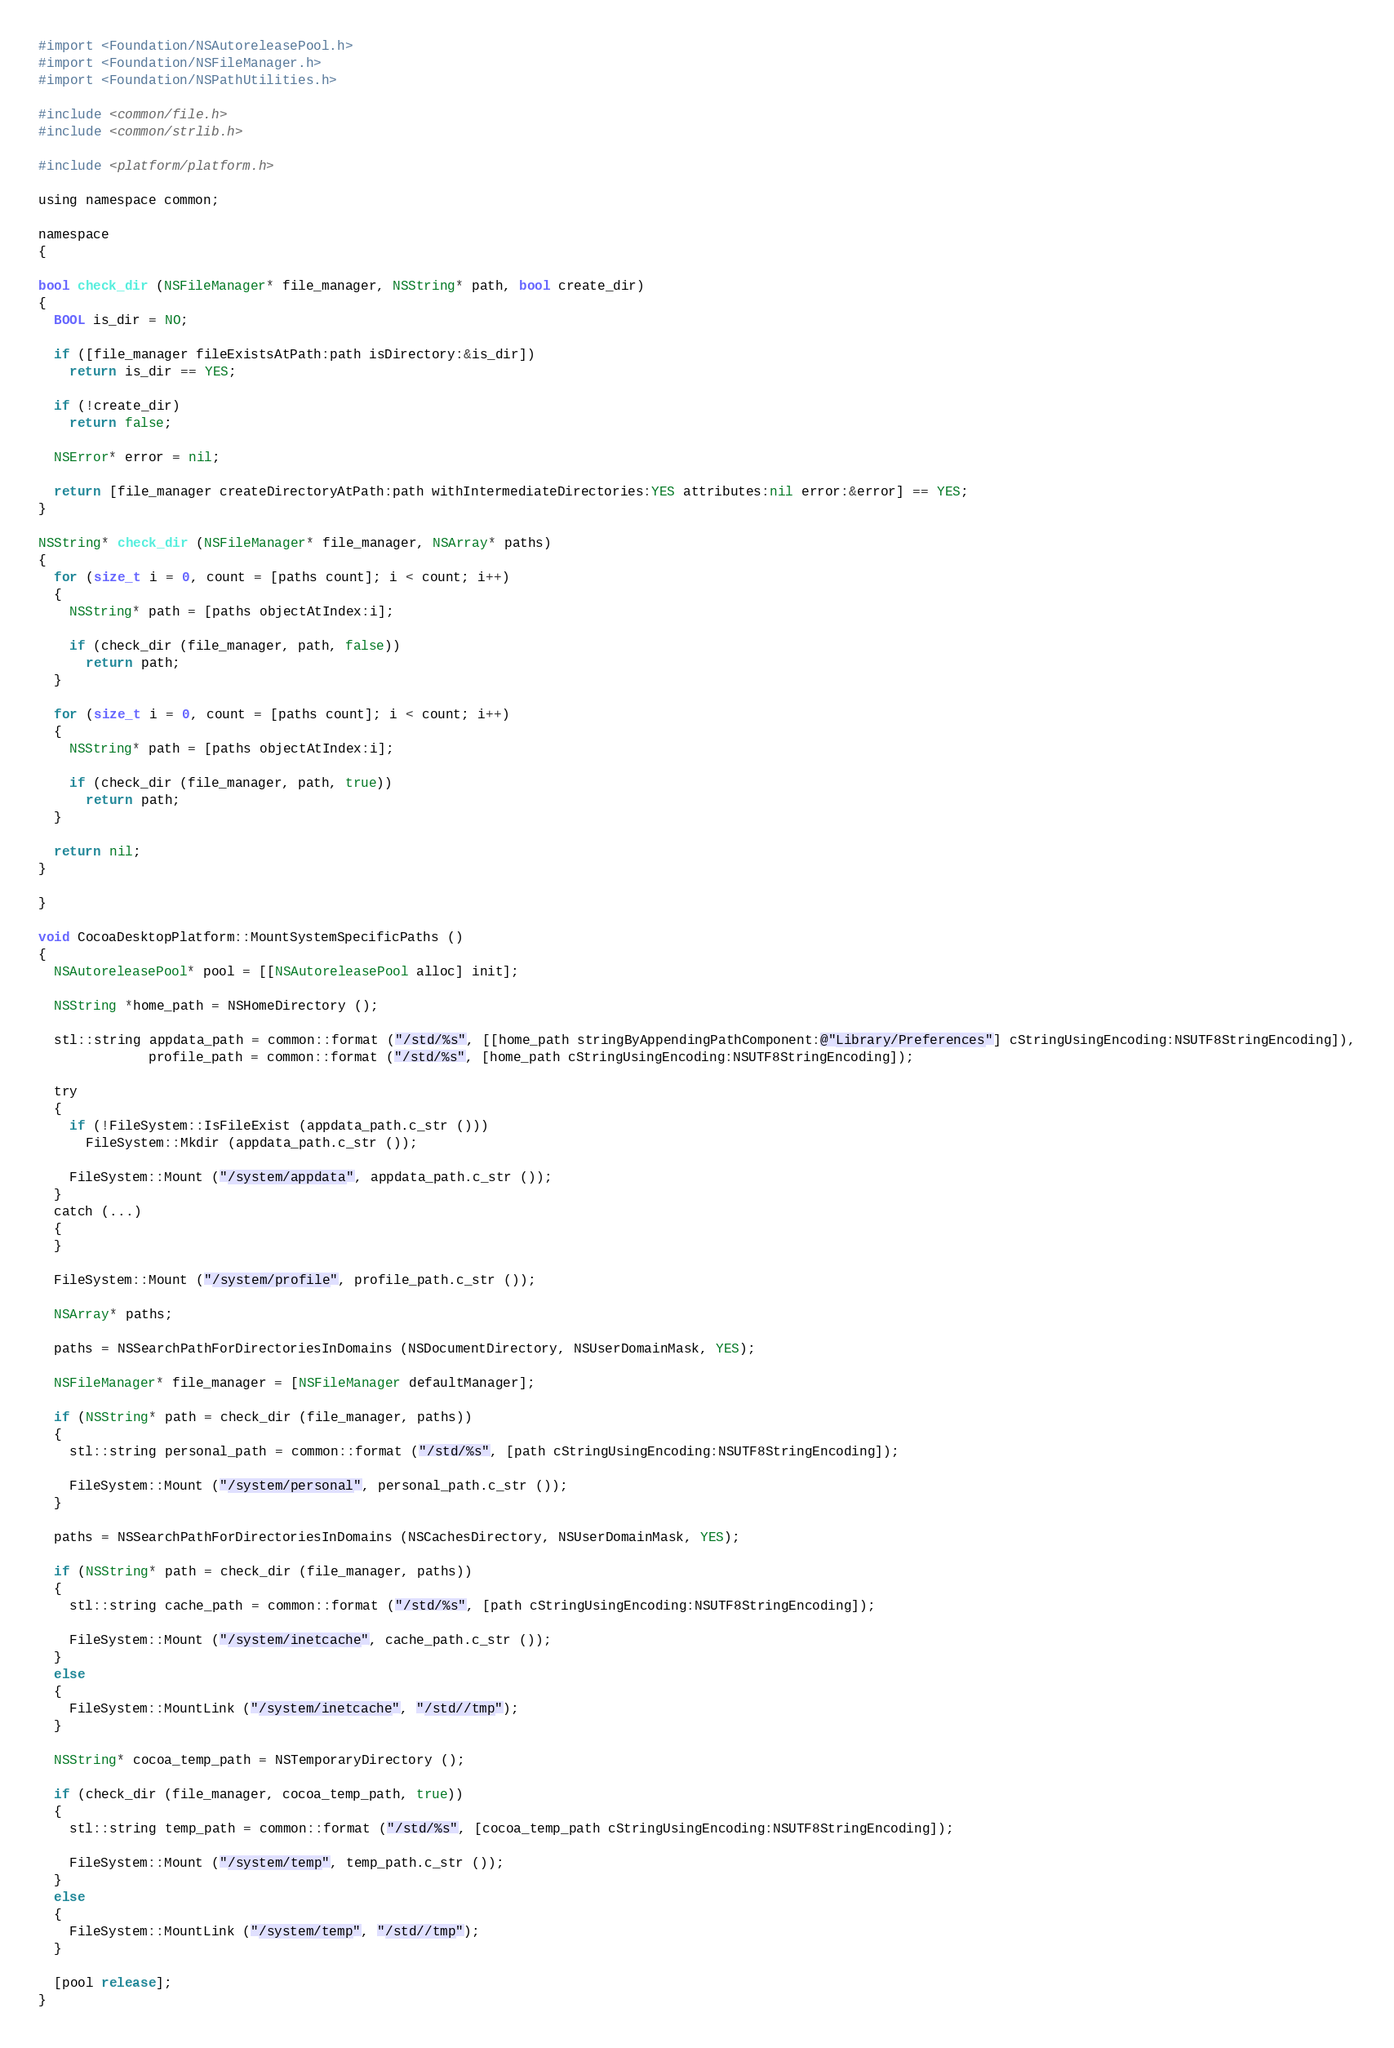Convert code to text. <code><loc_0><loc_0><loc_500><loc_500><_ObjectiveC_>#import <Foundation/NSAutoreleasePool.h>
#import <Foundation/NSFileManager.h>
#import <Foundation/NSPathUtilities.h>

#include <common/file.h>
#include <common/strlib.h>

#include <platform/platform.h>

using namespace common;

namespace
{

bool check_dir (NSFileManager* file_manager, NSString* path, bool create_dir)
{
  BOOL is_dir = NO;

  if ([file_manager fileExistsAtPath:path isDirectory:&is_dir])
    return is_dir == YES;

  if (!create_dir)
    return false;

  NSError* error = nil;

  return [file_manager createDirectoryAtPath:path withIntermediateDirectories:YES attributes:nil error:&error] == YES;
}

NSString* check_dir (NSFileManager* file_manager, NSArray* paths)
{
  for (size_t i = 0, count = [paths count]; i < count; i++)
  {
    NSString* path = [paths objectAtIndex:i];

    if (check_dir (file_manager, path, false))
      return path;
  }

  for (size_t i = 0, count = [paths count]; i < count; i++)
  {
    NSString* path = [paths objectAtIndex:i];

    if (check_dir (file_manager, path, true))
      return path;
  }

  return nil;
}

}

void CocoaDesktopPlatform::MountSystemSpecificPaths ()
{
  NSAutoreleasePool* pool = [[NSAutoreleasePool alloc] init];

  NSString *home_path = NSHomeDirectory ();

  stl::string appdata_path = common::format ("/std/%s", [[home_path stringByAppendingPathComponent:@"Library/Preferences"] cStringUsingEncoding:NSUTF8StringEncoding]),
              profile_path = common::format ("/std/%s", [home_path cStringUsingEncoding:NSUTF8StringEncoding]);

  try
  {
    if (!FileSystem::IsFileExist (appdata_path.c_str ()))
      FileSystem::Mkdir (appdata_path.c_str ());

    FileSystem::Mount ("/system/appdata", appdata_path.c_str ());
  }
  catch (...)
  {
  }

  FileSystem::Mount ("/system/profile", profile_path.c_str ());

  NSArray* paths;

  paths = NSSearchPathForDirectoriesInDomains (NSDocumentDirectory, NSUserDomainMask, YES);

  NSFileManager* file_manager = [NSFileManager defaultManager];

  if (NSString* path = check_dir (file_manager, paths))
  {
    stl::string personal_path = common::format ("/std/%s", [path cStringUsingEncoding:NSUTF8StringEncoding]);

    FileSystem::Mount ("/system/personal", personal_path.c_str ());
  }

  paths = NSSearchPathForDirectoriesInDomains (NSCachesDirectory, NSUserDomainMask, YES);

  if (NSString* path = check_dir (file_manager, paths))
  {
    stl::string cache_path = common::format ("/std/%s", [path cStringUsingEncoding:NSUTF8StringEncoding]);

    FileSystem::Mount ("/system/inetcache", cache_path.c_str ());
  }
  else
  {
    FileSystem::MountLink ("/system/inetcache", "/std//tmp");
  }

  NSString* cocoa_temp_path = NSTemporaryDirectory ();

  if (check_dir (file_manager, cocoa_temp_path, true))
  {
    stl::string temp_path = common::format ("/std/%s", [cocoa_temp_path cStringUsingEncoding:NSUTF8StringEncoding]);

    FileSystem::Mount ("/system/temp", temp_path.c_str ());
  }
  else
  {
    FileSystem::MountLink ("/system/temp", "/std//tmp");
  }

  [pool release];
}
</code> 